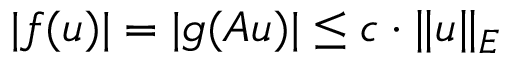<formula> <loc_0><loc_0><loc_500><loc_500>| f ( u ) | = | g ( A u ) | \leq c \cdot \| u \| _ { E }</formula> 